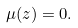<formula> <loc_0><loc_0><loc_500><loc_500>\mu ( z ) = 0 .</formula> 